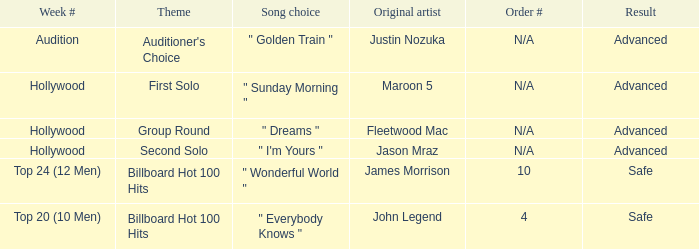For authentic maroon 5 artists, what are the various order numbers? N/A. 